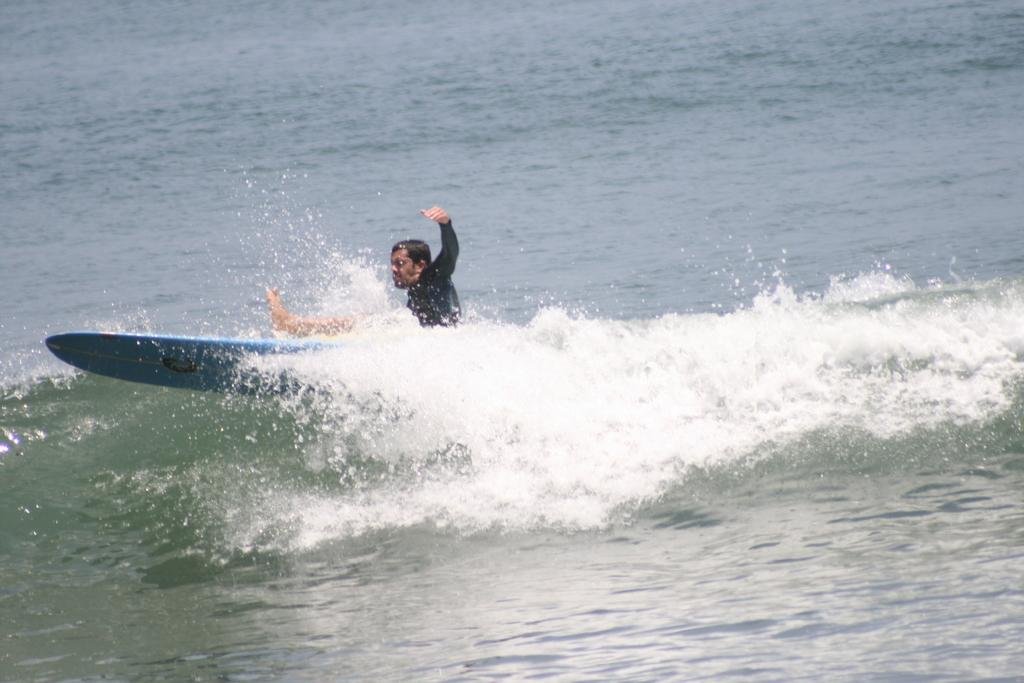Who is present in the image? There is a person in the image. What is the person doing in the image? The person is on a surfboard. Where is the surfboard located in the image? The surfboard is on the water. What type of education does the person need to join the surfing competition in the image? There is no indication in the image that the person is participating in a surfing competition, nor is there any mention of education requirements. 